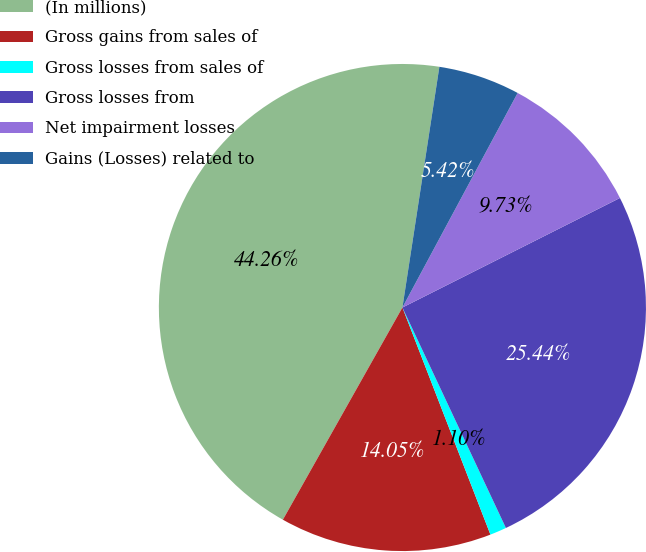Convert chart. <chart><loc_0><loc_0><loc_500><loc_500><pie_chart><fcel>(In millions)<fcel>Gross gains from sales of<fcel>Gross losses from sales of<fcel>Gross losses from<fcel>Net impairment losses<fcel>Gains (Losses) related to<nl><fcel>44.26%<fcel>14.05%<fcel>1.1%<fcel>25.44%<fcel>9.73%<fcel>5.42%<nl></chart> 